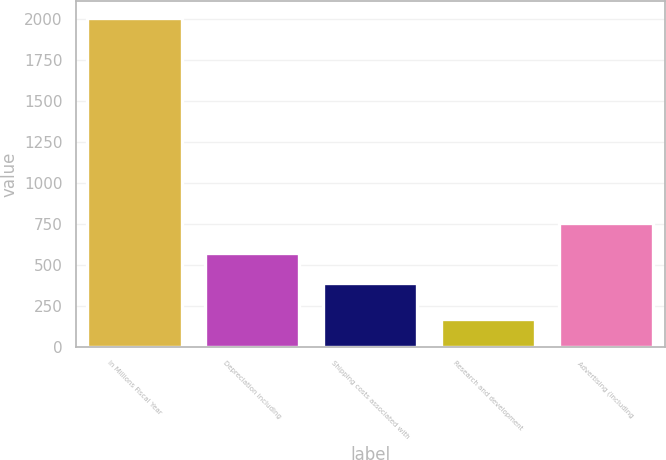<chart> <loc_0><loc_0><loc_500><loc_500><bar_chart><fcel>In Millions Fiscal Year<fcel>Depreciation including<fcel>Shipping costs associated with<fcel>Research and development<fcel>Advertising (including<nl><fcel>2005<fcel>571.7<fcel>388<fcel>168<fcel>755.4<nl></chart> 